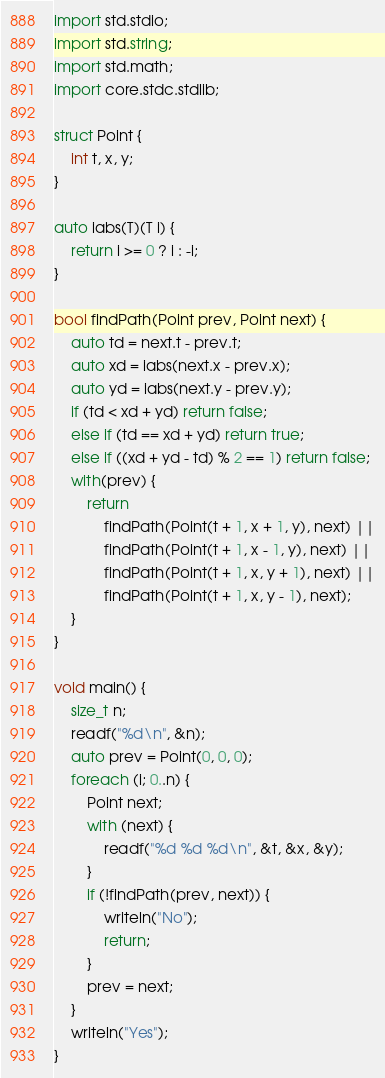Convert code to text. <code><loc_0><loc_0><loc_500><loc_500><_D_>import std.stdio;
import std.string;
import std.math;
import core.stdc.stdlib;

struct Point {
    int t, x, y;
}

auto iabs(T)(T i) {
    return i >= 0 ? i : -i;
}

bool findPath(Point prev, Point next) {
    auto td = next.t - prev.t;
    auto xd = iabs(next.x - prev.x);
    auto yd = iabs(next.y - prev.y);
    if (td < xd + yd) return false;
    else if (td == xd + yd) return true;
    else if ((xd + yd - td) % 2 == 1) return false;
    with(prev) {
        return
            findPath(Point(t + 1, x + 1, y), next) ||
            findPath(Point(t + 1, x - 1, y), next) ||
            findPath(Point(t + 1, x, y + 1), next) ||
            findPath(Point(t + 1, x, y - 1), next);
    }
}

void main() {
    size_t n;
    readf("%d\n", &n);
    auto prev = Point(0, 0, 0);
    foreach (i; 0..n) {
        Point next;
        with (next) {
            readf("%d %d %d\n", &t, &x, &y);
        }
        if (!findPath(prev, next)) {
            writeln("No");
            return;
        }
        prev = next;
    }
    writeln("Yes");
}
</code> 